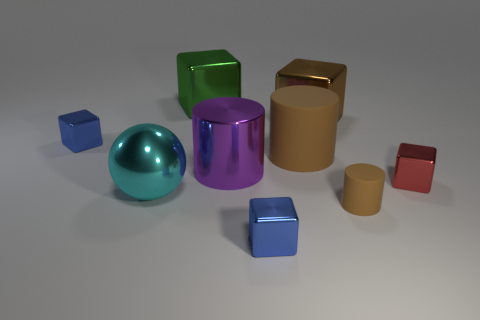How many large brown things are behind the big object to the right of the large brown cylinder? 0 